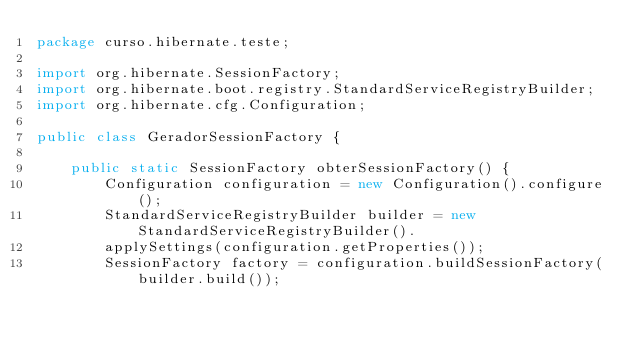Convert code to text. <code><loc_0><loc_0><loc_500><loc_500><_Java_>package curso.hibernate.teste;

import org.hibernate.SessionFactory;
import org.hibernate.boot.registry.StandardServiceRegistryBuilder;
import org.hibernate.cfg.Configuration;

public class GeradorSessionFactory {

	public static SessionFactory obterSessionFactory() {
		Configuration configuration = new Configuration().configure();
		StandardServiceRegistryBuilder builder = new StandardServiceRegistryBuilder().
		applySettings(configuration.getProperties());
		SessionFactory factory = configuration.buildSessionFactory(builder.build());</code> 